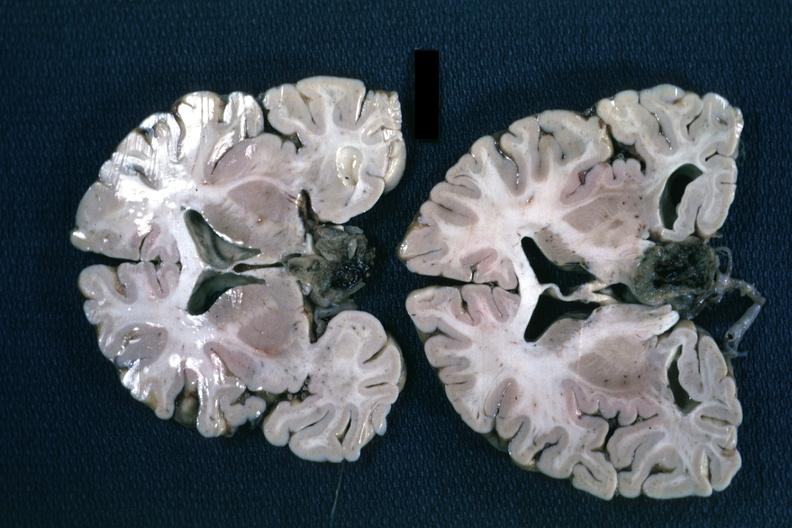s chromophobe adenoma present?
Answer the question using a single word or phrase. Yes 